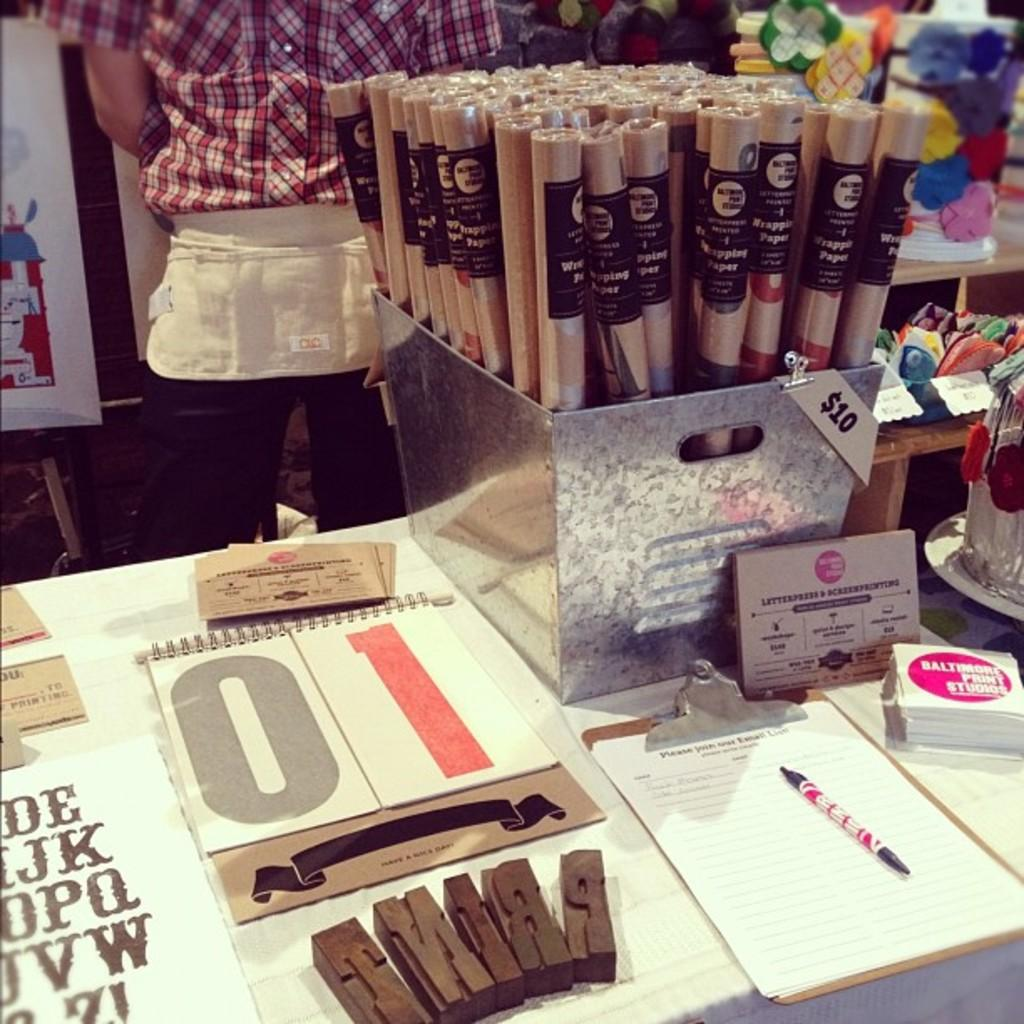Who is in the image? There is a man in the image. What is the man standing near? The man is standing near a steel box. What items can be seen related to writing or documentation? Papers, a pad, and a pen are visible in the image. What type of paper is present for wiping or blowing one's nose? Tissue papers are present in the image. What other objects are in the image? There are other objects in the image, but their specific details are not mentioned in the provided facts. What is inside the steel box? Flutes are inside the steel box. How many cows are grazing in the territory shown in the image? There are no cows or territory present in the image; it features a man standing near a steel box with various objects around him. 